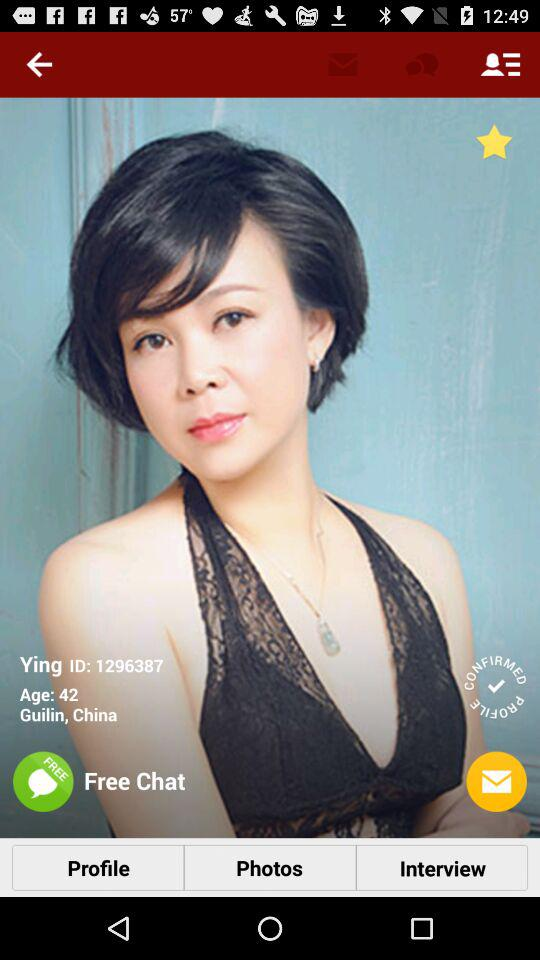What is the age given for Ying? The age is 42 years. 